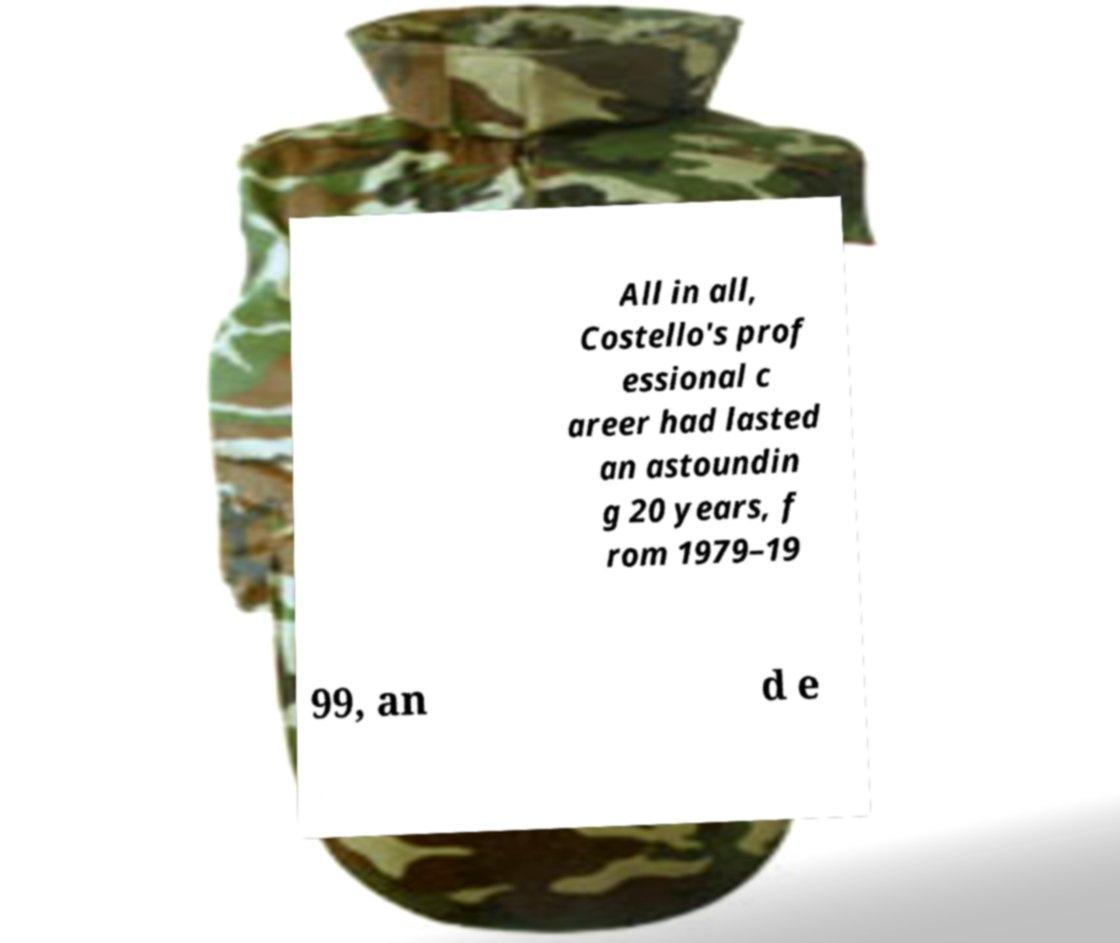For documentation purposes, I need the text within this image transcribed. Could you provide that? All in all, Costello's prof essional c areer had lasted an astoundin g 20 years, f rom 1979–19 99, an d e 